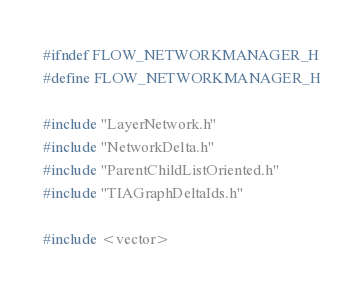<code> <loc_0><loc_0><loc_500><loc_500><_C_>#ifndef FLOW_NETWORKMANAGER_H
#define FLOW_NETWORKMANAGER_H

#include "LayerNetwork.h"
#include "NetworkDelta.h"
#include "ParentChildListOriented.h"
#include "TIAGraphDeltaIds.h"

#include <vector></code> 